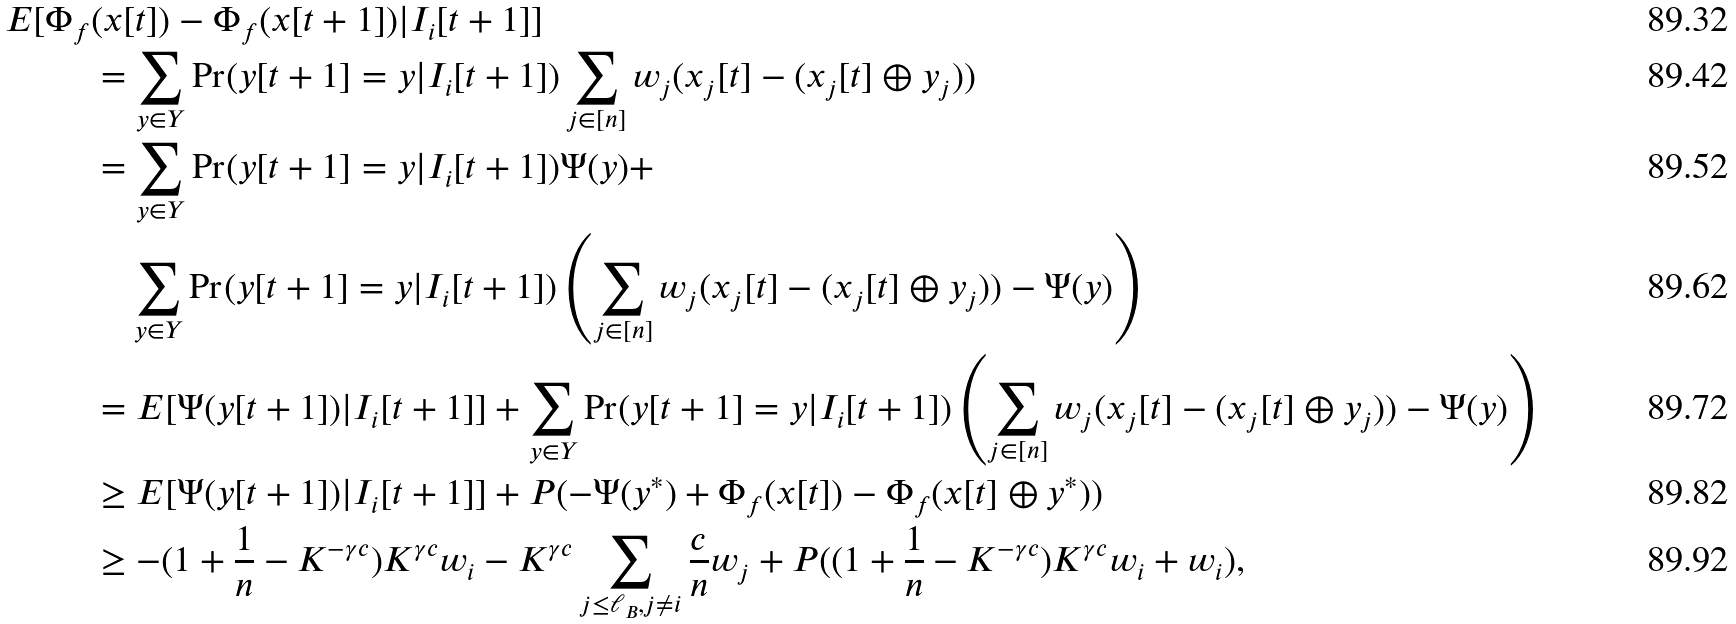Convert formula to latex. <formula><loc_0><loc_0><loc_500><loc_500>E [ \Phi _ { f } & ( x [ t ] ) - \Phi _ { f } ( x [ t + 1 ] ) | I _ { i } [ t + 1 ] ] \\ & = \sum _ { y \in Y } \Pr ( y [ t + 1 ] = y | I _ { i } [ t + 1 ] ) \sum _ { j \in [ n ] } w _ { j } ( x _ { j } [ t ] - ( x _ { j } [ t ] \oplus y _ { j } ) ) \\ & = \sum _ { y \in Y } \Pr ( y [ t + 1 ] = y | I _ { i } [ t + 1 ] ) \Psi ( y ) + \\ & \quad \sum _ { y \in Y } \Pr ( y [ t + 1 ] = y | I _ { i } [ t + 1 ] ) \left ( \sum _ { j \in [ n ] } w _ { j } ( x _ { j } [ t ] - ( x _ { j } [ t ] \oplus y _ { j } ) ) - \Psi ( y ) \right ) \\ & = E [ \Psi ( y [ t + 1 ] ) | I _ { i } [ t + 1 ] ] + \sum _ { y \in Y } \Pr ( y [ t + 1 ] = y | I _ { i } [ t + 1 ] ) \left ( \sum _ { j \in [ n ] } w _ { j } ( x _ { j } [ t ] - ( x _ { j } [ t ] \oplus y _ { j } ) ) - \Psi ( y ) \right ) \\ & \geq E [ \Psi ( y [ t + 1 ] ) | I _ { i } [ t + 1 ] ] + P ( - \Psi ( y ^ { * } ) + \Phi _ { f } ( x [ t ] ) - \Phi _ { f } ( x [ t ] \oplus y ^ { * } ) ) \\ & \geq - ( 1 + \frac { 1 } { n } - K ^ { - \gamma c } ) K ^ { \gamma c } w _ { i } - K ^ { \gamma c } \sum _ { j \leq \ell _ { B } , j \neq i } \frac { c } { n } w _ { j } + P ( ( 1 + \frac { 1 } { n } - K ^ { - \gamma c } ) K ^ { \gamma c } w _ { i } + w _ { i } ) ,</formula> 